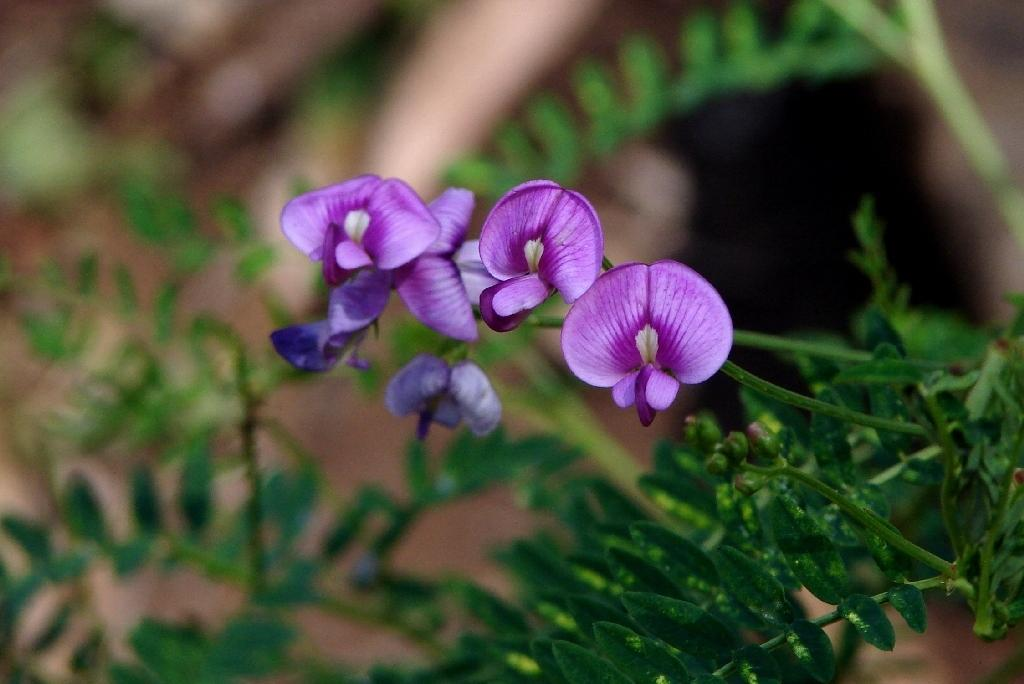What type of plant parts can be seen in the image? Leaves, buds, flowers, and stems can be seen in the image. Can you describe the stage of growth for the plants in the image? The presence of buds and flowers suggests that the plants are in a blooming stage. What is the background of the image like? The background of the image is blurry. What type of farmer is shown selecting the best plants in the image? There is no farmer present in the image, and no selection process is depicted. 